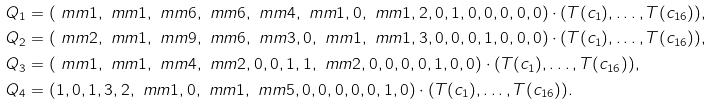<formula> <loc_0><loc_0><loc_500><loc_500>Q _ { 1 } & = ( \ m m 1 , \ m m 1 , \ m m 6 , \ m m 6 , \ m m 4 , \ m m 1 , 0 , \ m m 1 , 2 , 0 , 1 , 0 , 0 , 0 , 0 , 0 ) \cdot ( T ( c _ { 1 } ) , \dots , T ( c _ { 1 6 } ) ) , \\ Q _ { 2 } & = ( \ m m 2 , \ m m 1 , \ m m 9 , \ m m 6 , \ m m 3 , 0 , \ m m 1 , \ m m 1 , 3 , 0 , 0 , 0 , 1 , 0 , 0 , 0 ) \cdot ( T ( c _ { 1 } ) , \dots , T ( c _ { 1 6 } ) ) , \\ Q _ { 3 } & = ( \ m m 1 , \ m m 1 , \ m m 4 , \ m m 2 , 0 , 0 , 1 , 1 , \ m m 2 , 0 , 0 , 0 , 0 , 1 , 0 , 0 ) \cdot ( T ( c _ { 1 } ) , \dots , T ( c _ { 1 6 } ) ) , \\ Q _ { 4 } & = ( 1 , 0 , 1 , 3 , 2 , \ m m 1 , 0 , \ m m 1 , \ m m 5 , 0 , 0 , 0 , 0 , 0 , 1 , 0 ) \cdot ( T ( c _ { 1 } ) , \dots , T ( c _ { 1 6 } ) ) .</formula> 